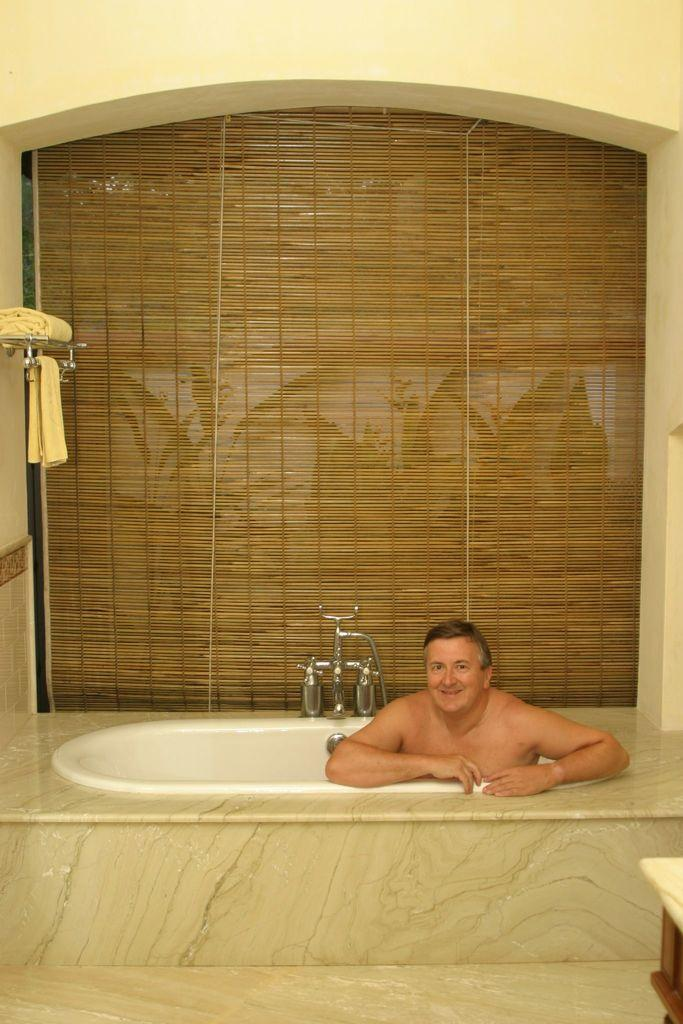What is the man in the image doing? The man is in the bathtub in the image. What is the man's facial expression in the image? The man is smiling in the image. What can be seen near the bathtub in the image? There are taps visible in the image. What items might be used for drying after a bath in the image? There are towels in the image. What is used to provide privacy in the image? There is a curtain in the image. What type of structure is visible in the image? There is a wall in the image. What object is on the floor in the image? There is an object on the floor in the image. What type of train is visible in the image? There is no train present in the image. What is the value of the nest in the image? There is no nest present in the image. 